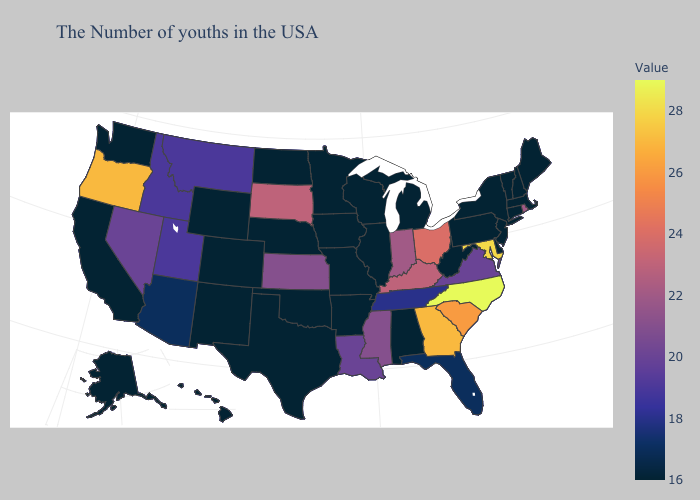Does the map have missing data?
Keep it brief. No. 